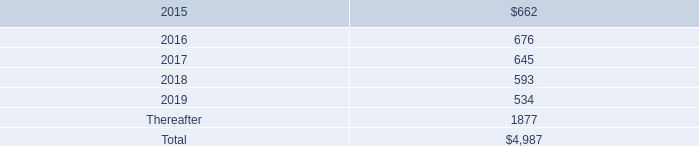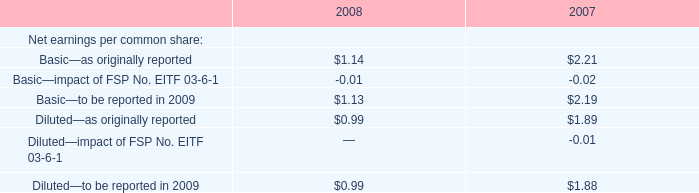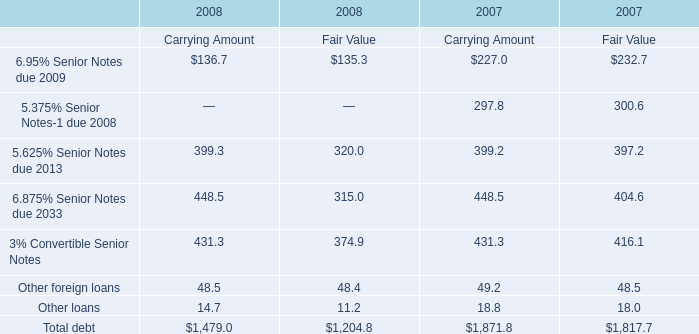as of september 27 , 2014 , what percentage of the company 2019s total future minimum lease payments under noncancelable operating leases related to leases for retail space? 
Computations: (3.6 / 5)
Answer: 0.72. 